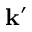Convert formula to latex. <formula><loc_0><loc_0><loc_500><loc_500>k ^ { \prime }</formula> 